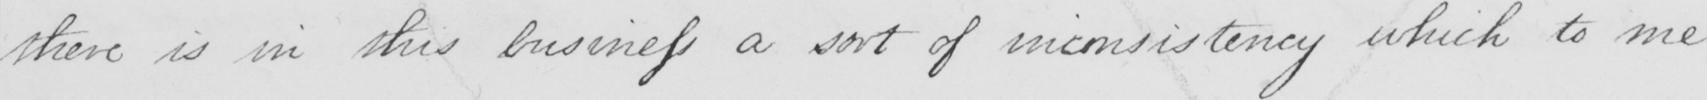What is written in this line of handwriting? there is in this business a sort of inconsistency which to me 